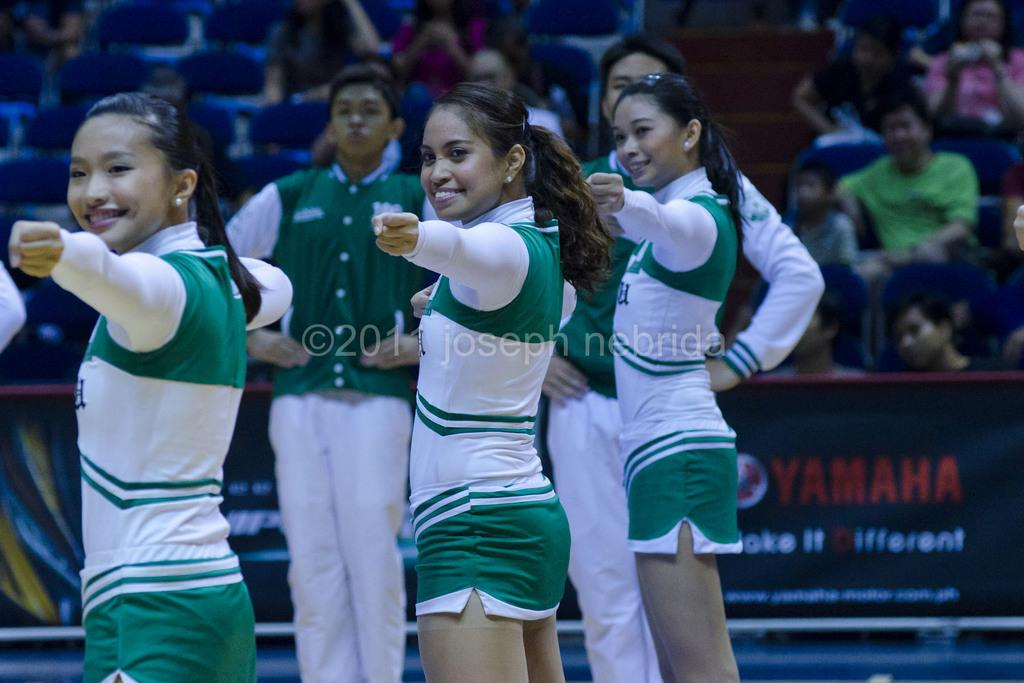How many people are smiling in the image? There are three persons standing and smiling in the image. Can you describe the people in the background? In the background, there are two persons standing, and there is a group of people sitting on chairs. What is visible in the background besides the people? There is a board visible in the background. What type of industry is depicted in the image? There is no specific industry depicted in the image; it features people standing and smiling, as well as a group of people sitting and a board in the background. Is there a jail visible in the image? No, there is no jail present in the image. 